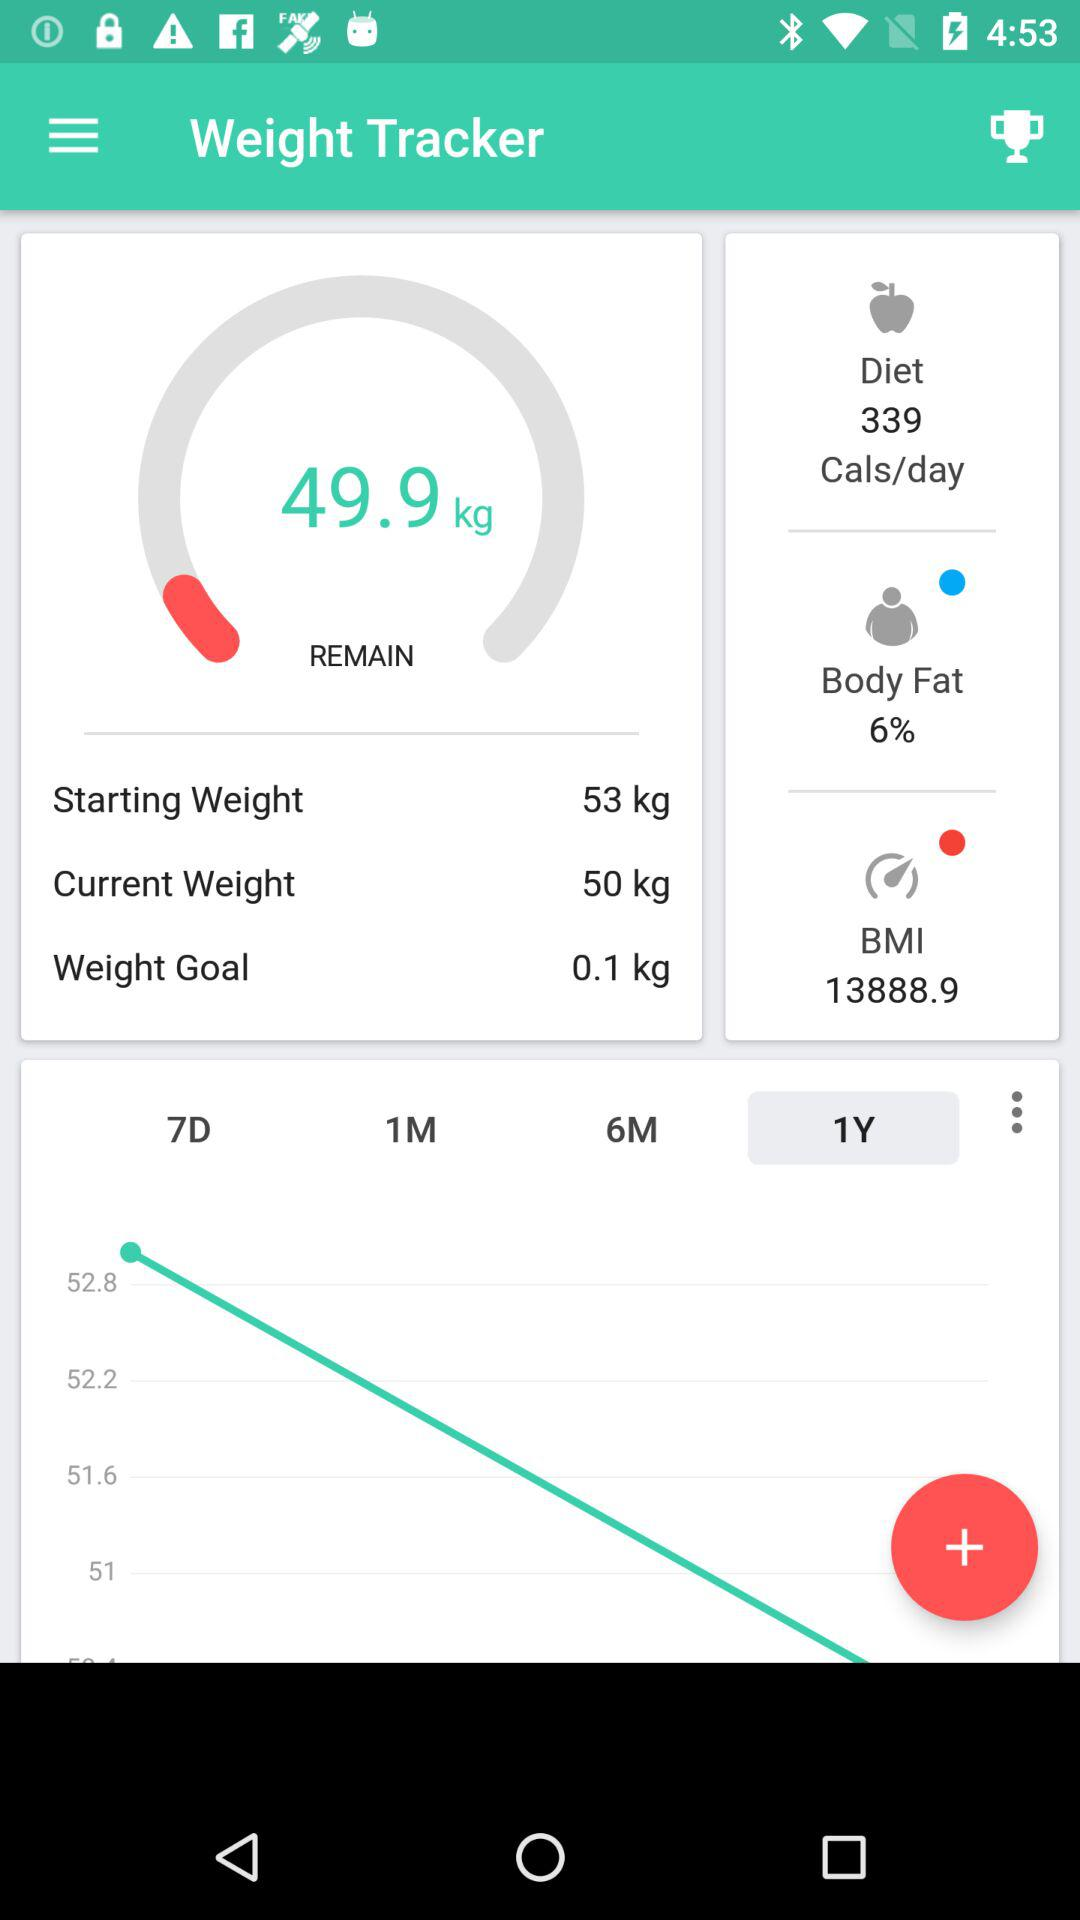How much is the BMI? The BMI is 13888.9. 